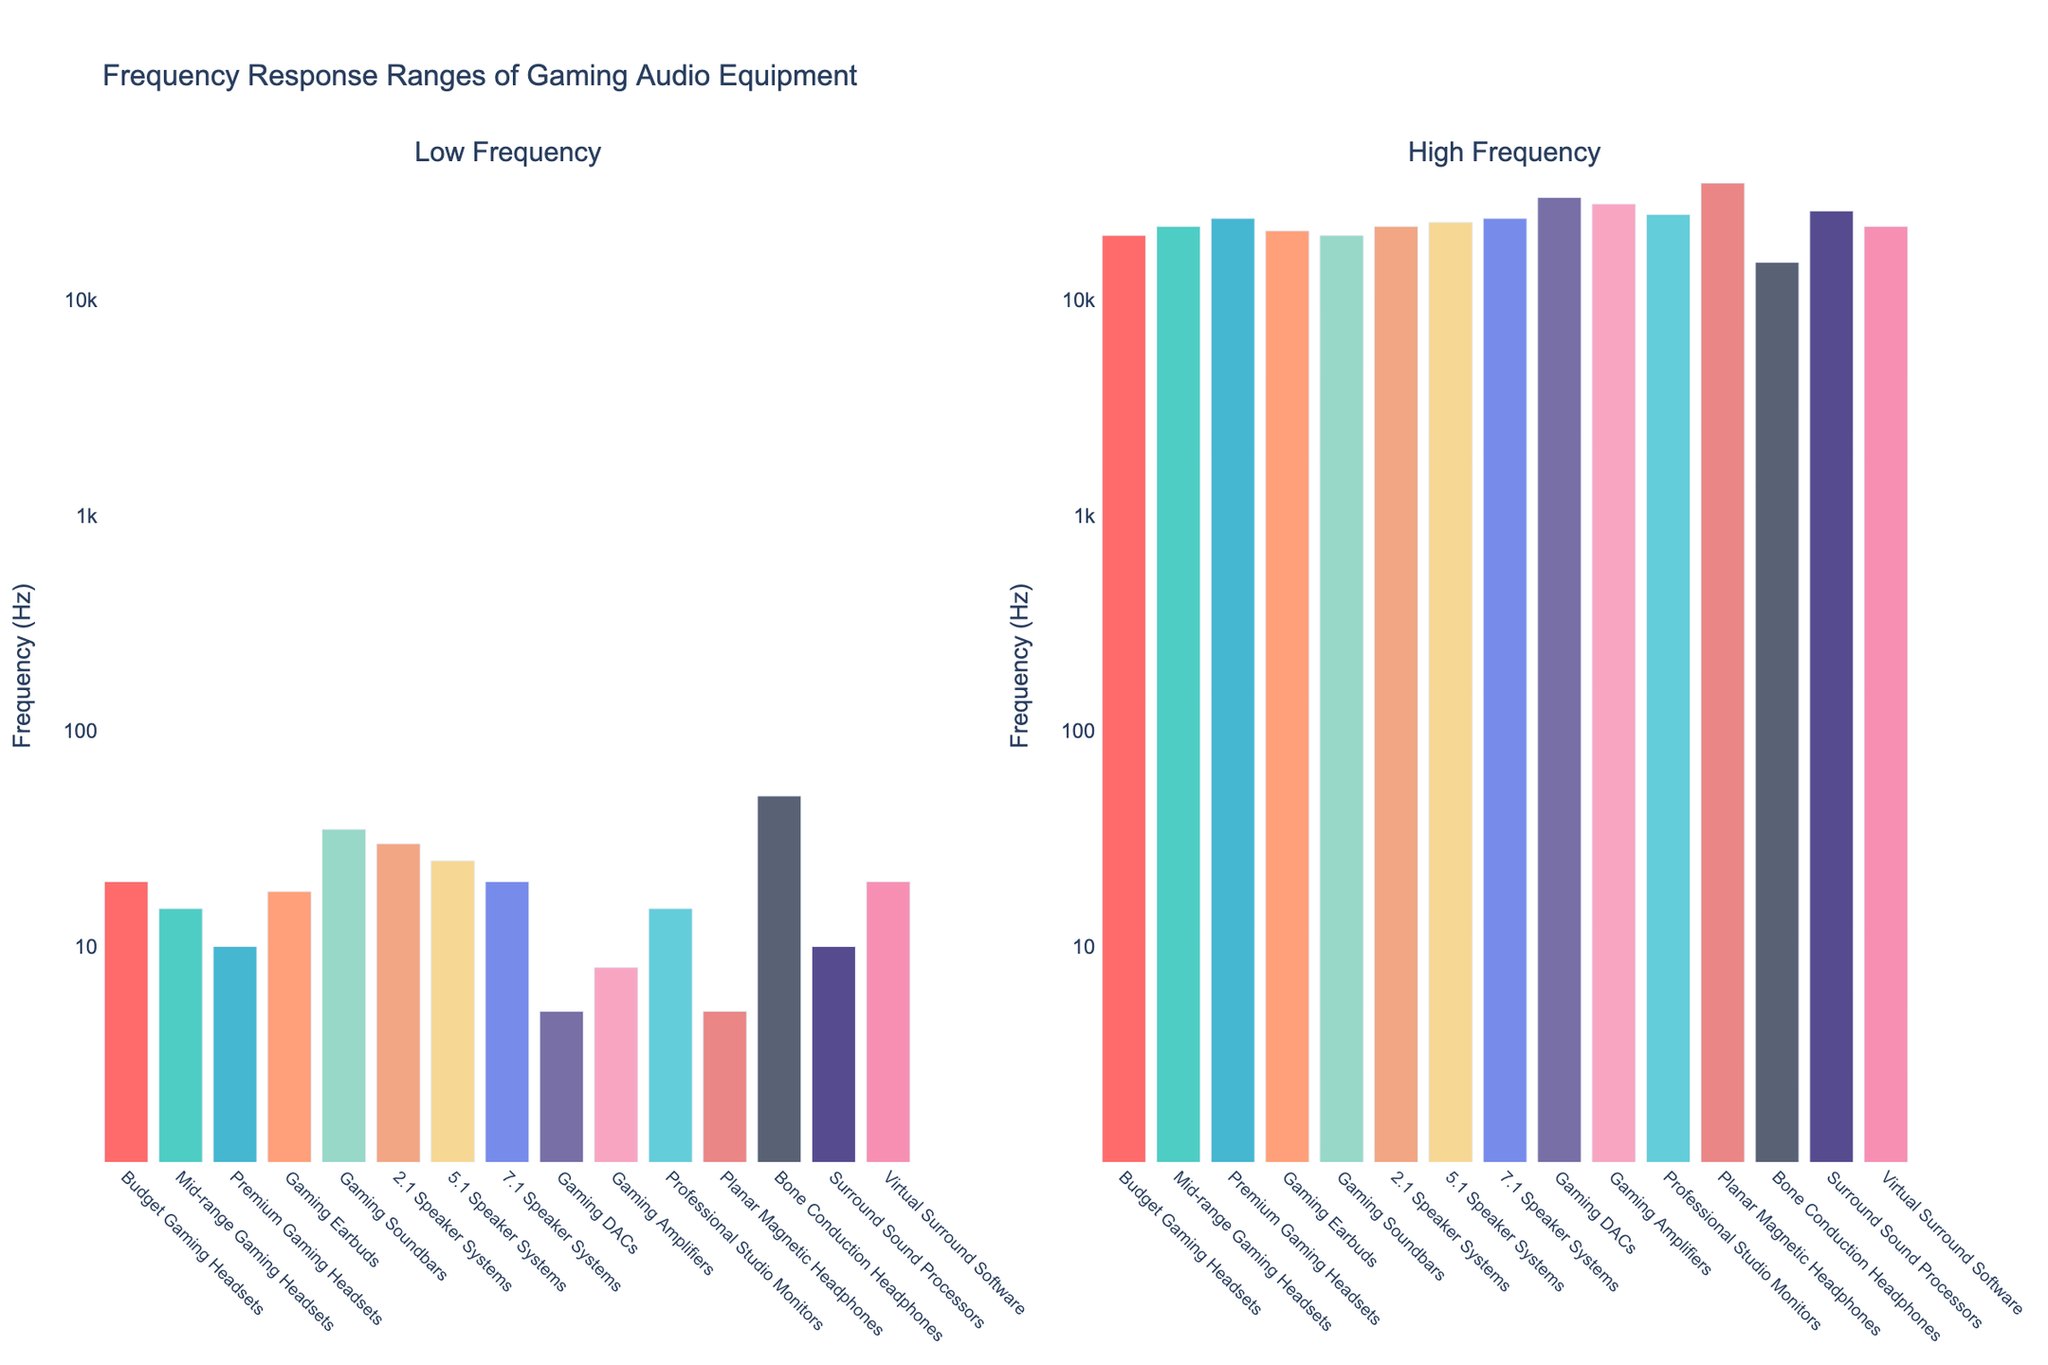What category has the lowest high-frequency value? First, identify the 'High Frequency' bars and their respective categories. Find the category with the shortest bar in the 'High Frequency' subplot. The Bone Conduction Headphones have the shortest bar at 15,000 Hz.
Answer: Bone Conduction Headphones Which audio equipment category has the highest low-frequency value, and what is that value? Look at the 'Low Frequency' subplot and find the category with the tallest bar. The Bone Conduction Headphones have the highest low-frequency value at 50 Hz.
Answer: Bone Conduction Headphones, 50 Hz What is the difference in high-frequency response between the Premium Gaming Headsets and the 7.1 Speaker Systems? Check the 'High Frequency' values for both categories. The Premium Gaming Headsets reach up to 24,000 Hz while the 7.1 Speaker Systems also reach up to 24,000 Hz. Calculate the difference: 24,000 Hz - 24,000 Hz = 0 Hz.
Answer: 0 Hz Which category has a wider frequency response range: Gaming DACs or Professional Studio Monitors? Calculate the range for both categories. Gaming DACs: 30,000 Hz - 5 Hz = 29,995 Hz. Professional Studio Monitors: 25,000 Hz - 15 Hz = 24,985 Hz. Compare the results.
Answer: Gaming DACs How many categories have a low-frequency response of 20 Hz? Count the number of bars in the 'Low Frequency' subplot where the value corresponds to 20 Hz. These categories are Budget Gaming Headsets, 7.1 Speaker Systems, and Virtual Surround Software, making a total of 3 categories.
Answer: 3 categories Which two categories have the highest maximum high-frequency response values? Identify the two tallest bars in the 'High Frequency' subplot. These belong to Planar Magnetic Headphones and Gaming DACs.
Answer: Planar Magnetic Headphones, Gaming DACs What is the average high-frequency response of Mid-range Gaming Headsets, Gaming Soundbars, and 7.1 Speaker Systems? Check the high-frequency values for each of the three categories: Mid-range Gaming Headsets (22,000 Hz), Gaming Soundbars (20,000 Hz), and 7.1 Speaker Systems (24,000 Hz). Calculate the average: (22,000 + 20,000 + 24,000) / 3 = 22,000 Hz.
Answer: 22,000 Hz Which category shows the smallest low-frequency value and what is that value? Look at the 'Low Frequency' subplot and identify the category with the shortest bar. The Gaming DACs and Planar Magnetic Headphones both have the smallest low-frequency value of 5 Hz.
Answer: Gaming DACs, Planar Magnetic Headphones, 5 Hz Between Gaming Amplifiers and Surround Sound Processors, which category has a narrower frequency response range? Calculate the range for each category. Gaming Amplifiers: 28,000 Hz - 8 Hz = 27,992 Hz. Surround Sound Processors: 26,000 Hz - 10 Hz = 25,990 Hz. Compare the results.
Answer: Surround Sound Processors 